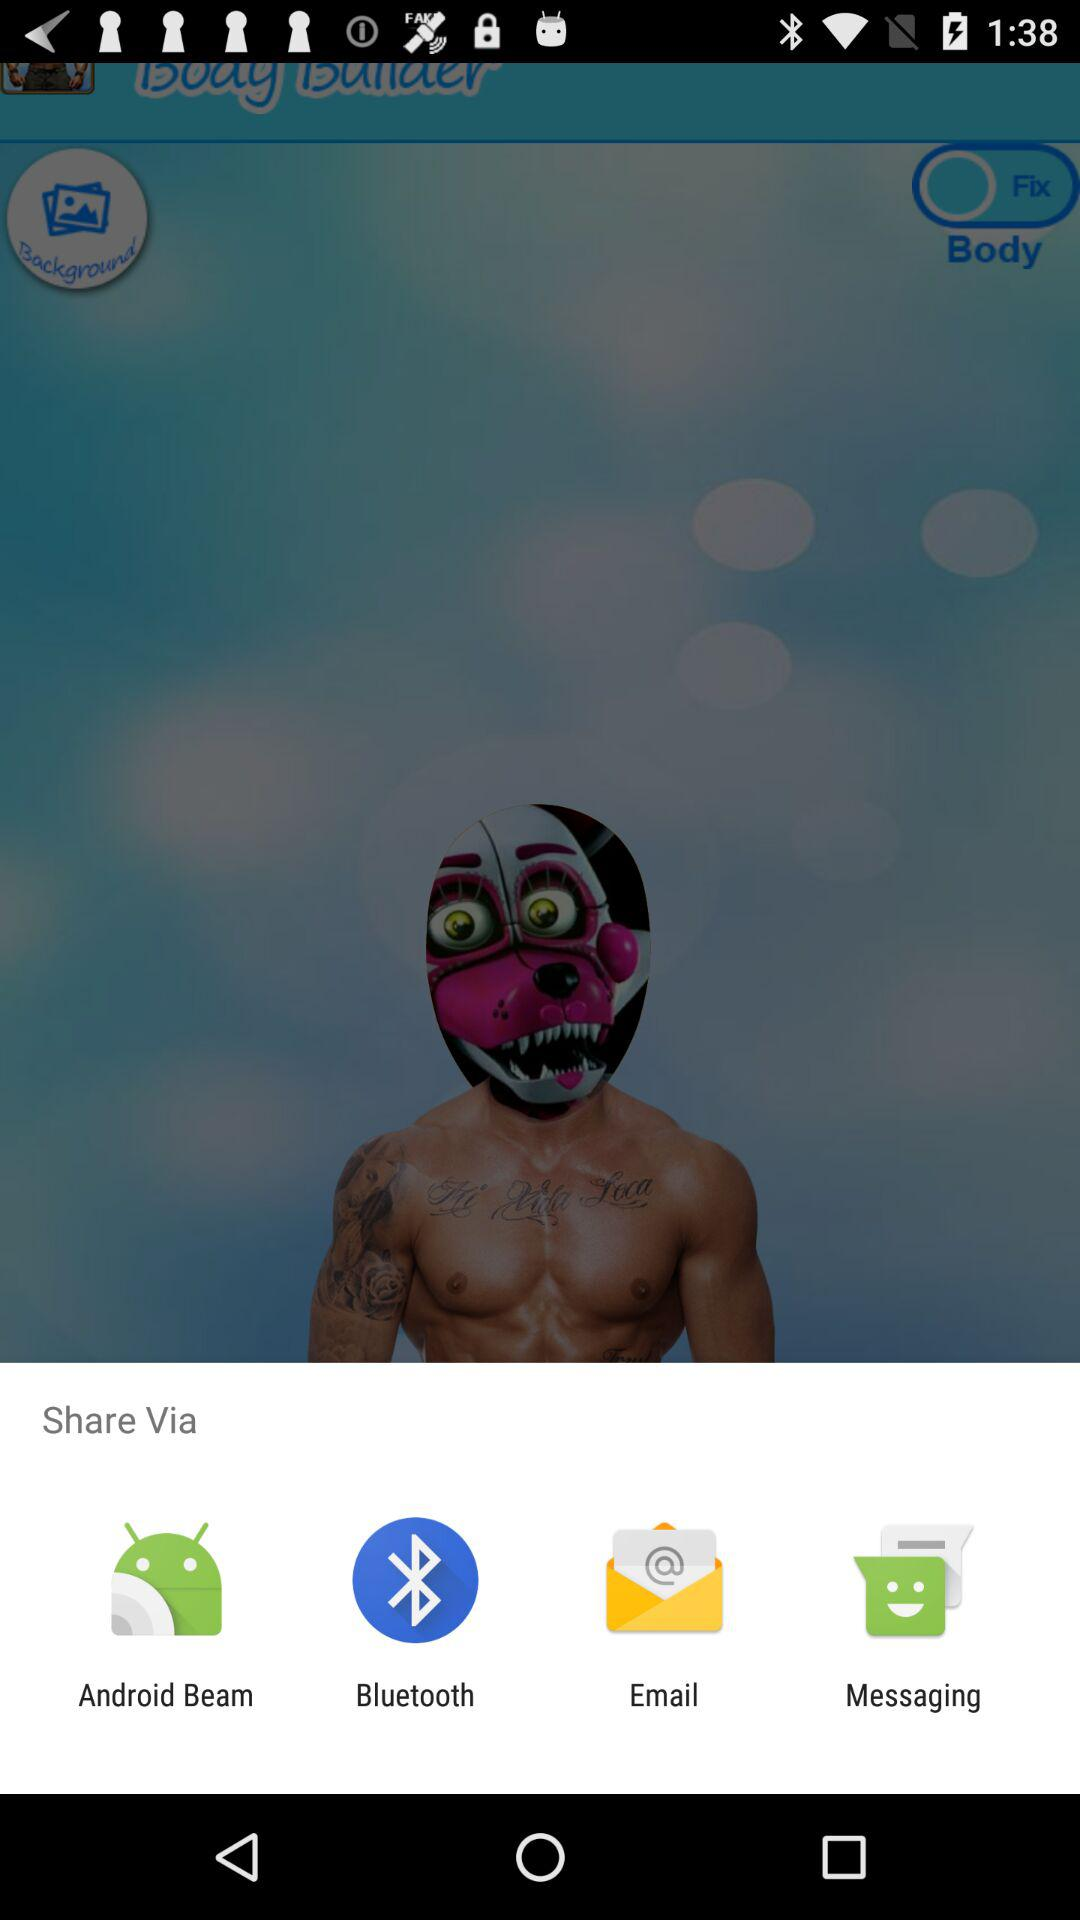What are the sharing options? The sharing options are "Android Beam", "Bluetooth", "Email" and "Messaging". 